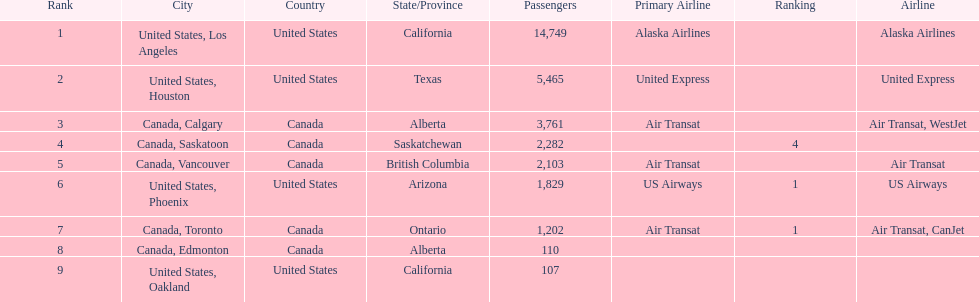Which airline carries the most passengers? Alaska Airlines. Parse the table in full. {'header': ['Rank', 'City', 'Country', 'State/Province', 'Passengers', 'Primary Airline', 'Ranking', 'Airline'], 'rows': [['1', 'United States, Los Angeles', 'United States', 'California', '14,749', 'Alaska Airlines', '', 'Alaska Airlines'], ['2', 'United States, Houston', 'United States', 'Texas', '5,465', 'United Express', '', 'United Express'], ['3', 'Canada, Calgary', 'Canada', 'Alberta', '3,761', 'Air Transat', '', 'Air Transat, WestJet'], ['4', 'Canada, Saskatoon', 'Canada', 'Saskatchewan', '2,282', '', '4', ''], ['5', 'Canada, Vancouver', 'Canada', 'British Columbia', '2,103', 'Air Transat', '', 'Air Transat'], ['6', 'United States, Phoenix', 'United States', 'Arizona', '1,829', 'US Airways', '1', 'US Airways'], ['7', 'Canada, Toronto', 'Canada', 'Ontario', '1,202', 'Air Transat', '1', 'Air Transat, CanJet'], ['8', 'Canada, Edmonton', 'Canada', 'Alberta', '110', '', '', ''], ['9', 'United States, Oakland', 'United States', 'California', '107', '', '', '']]} 